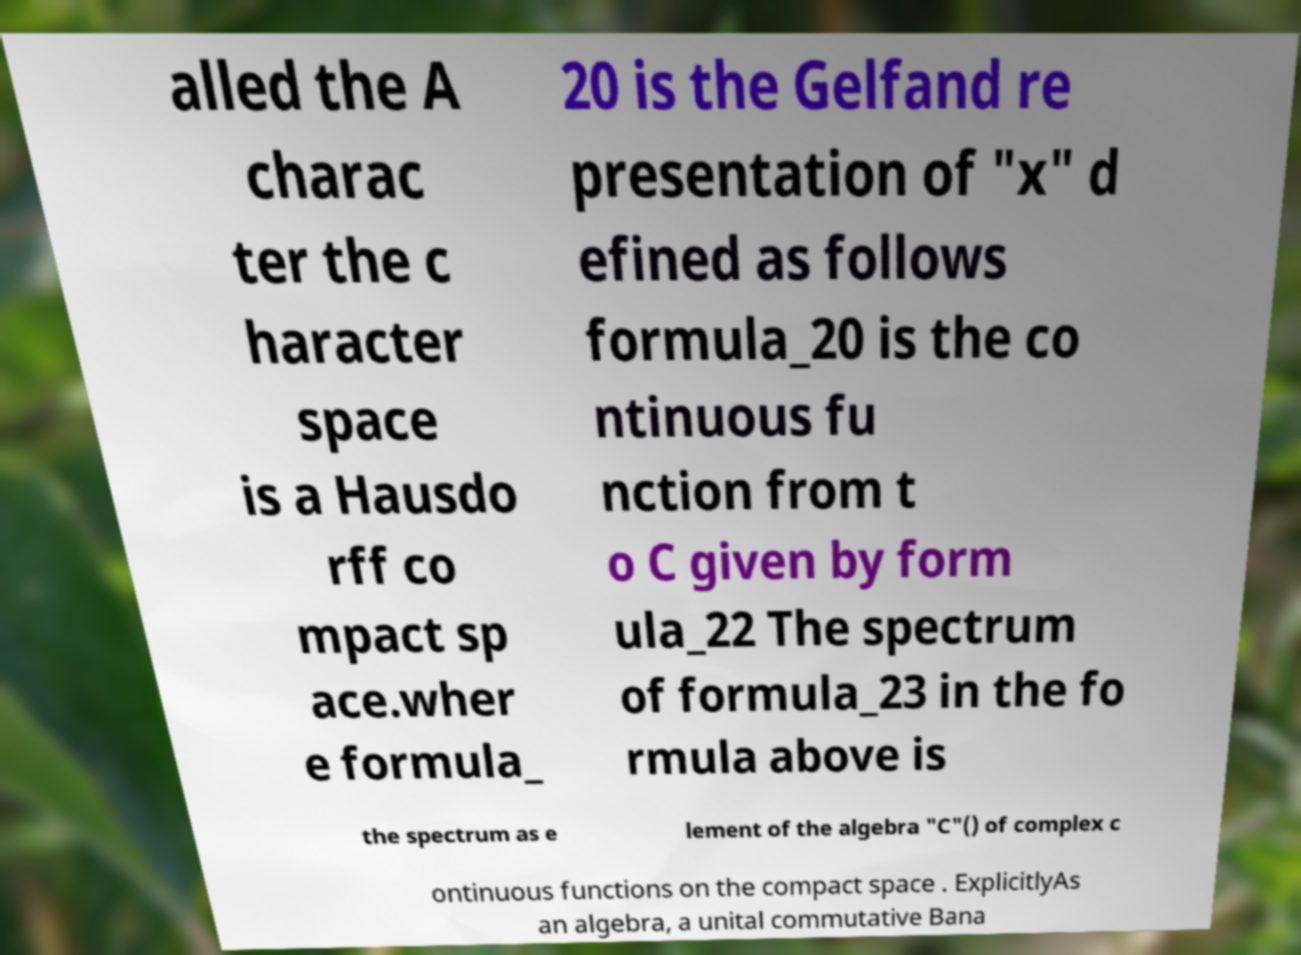Please read and relay the text visible in this image. What does it say? alled the A charac ter the c haracter space is a Hausdo rff co mpact sp ace.wher e formula_ 20 is the Gelfand re presentation of "x" d efined as follows formula_20 is the co ntinuous fu nction from t o C given by form ula_22 The spectrum of formula_23 in the fo rmula above is the spectrum as e lement of the algebra "C"() of complex c ontinuous functions on the compact space . ExplicitlyAs an algebra, a unital commutative Bana 